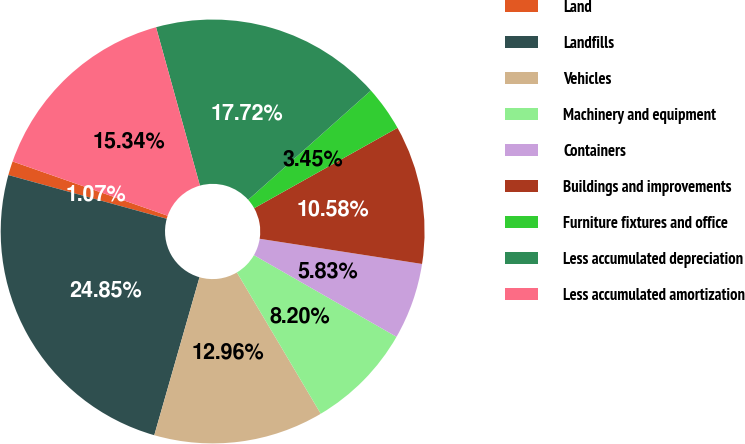<chart> <loc_0><loc_0><loc_500><loc_500><pie_chart><fcel>Land<fcel>Landfills<fcel>Vehicles<fcel>Machinery and equipment<fcel>Containers<fcel>Buildings and improvements<fcel>Furniture fixtures and office<fcel>Less accumulated depreciation<fcel>Less accumulated amortization<nl><fcel>1.07%<fcel>24.85%<fcel>12.96%<fcel>8.2%<fcel>5.83%<fcel>10.58%<fcel>3.45%<fcel>17.72%<fcel>15.34%<nl></chart> 